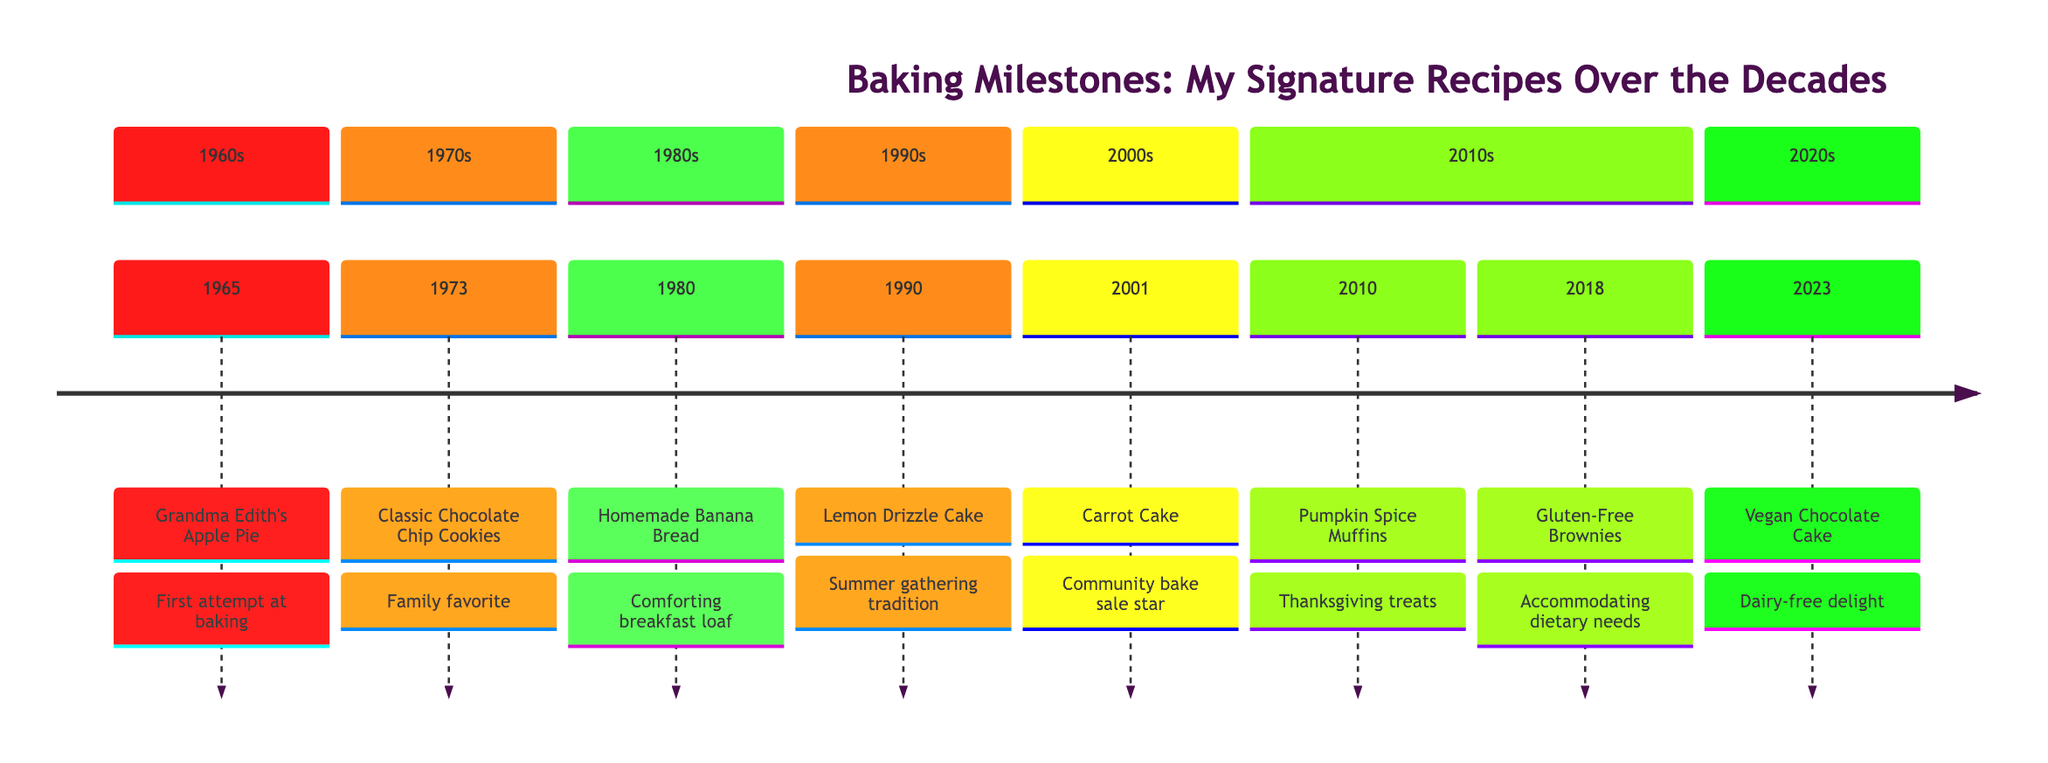What year was Grandma Edith's Apple Pie first baked? The timeline indicates the year next to Grandma Edith's Apple Pie, which is 1965.
Answer: 1965 How many recipes are listed on the timeline? By counting the number of recipe entries in the timeline, I find there are eight distinct recipes mentioned.
Answer: 8 Which recipe was introduced in 1990? Referring to the timeline for the year 1990, it clearly shows that the recipe is Lemon Drizzle Cake.
Answer: Lemon Drizzle Cake What milestone is associated with the Classic Chocolate Chip Cookies? The timeline specifies the milestone next to Classic Chocolate Chip Cookies, which is that they became a family favorite baked for birthday parties.
Answer: Family favorite What unique feature does the Vegan Chocolate Cake have? Looking at the note beside Vegan Chocolate Cake, it highlights that it is moist, rich, and topped with a velvety ganache, emphasizing that it does not require dairy.
Answer: Dairy-free delight In what decade was the Carrot Cake with Cream Cheese Frosting recognized? The timeline shows that Carrot Cake with Cream Cheese Frosting was baked in the year 2001, which is in the 2000s decade.
Answer: 2000s How did the recipe for Gluten-Free Brownies come into existence? The explanation shows that the recipe was developed to accommodate dietary needs of family and friends, making it necessary to create a gluten-free option.
Answer: Dietary needs Which recipe was popular during Thanksgiving celebrations? Referring to the timeline, the recipe associated with Thanksgiving celebrations is Pumpkin Spice Muffins, as noted in the year 2010.
Answer: Pumpkin Spice Muffins 